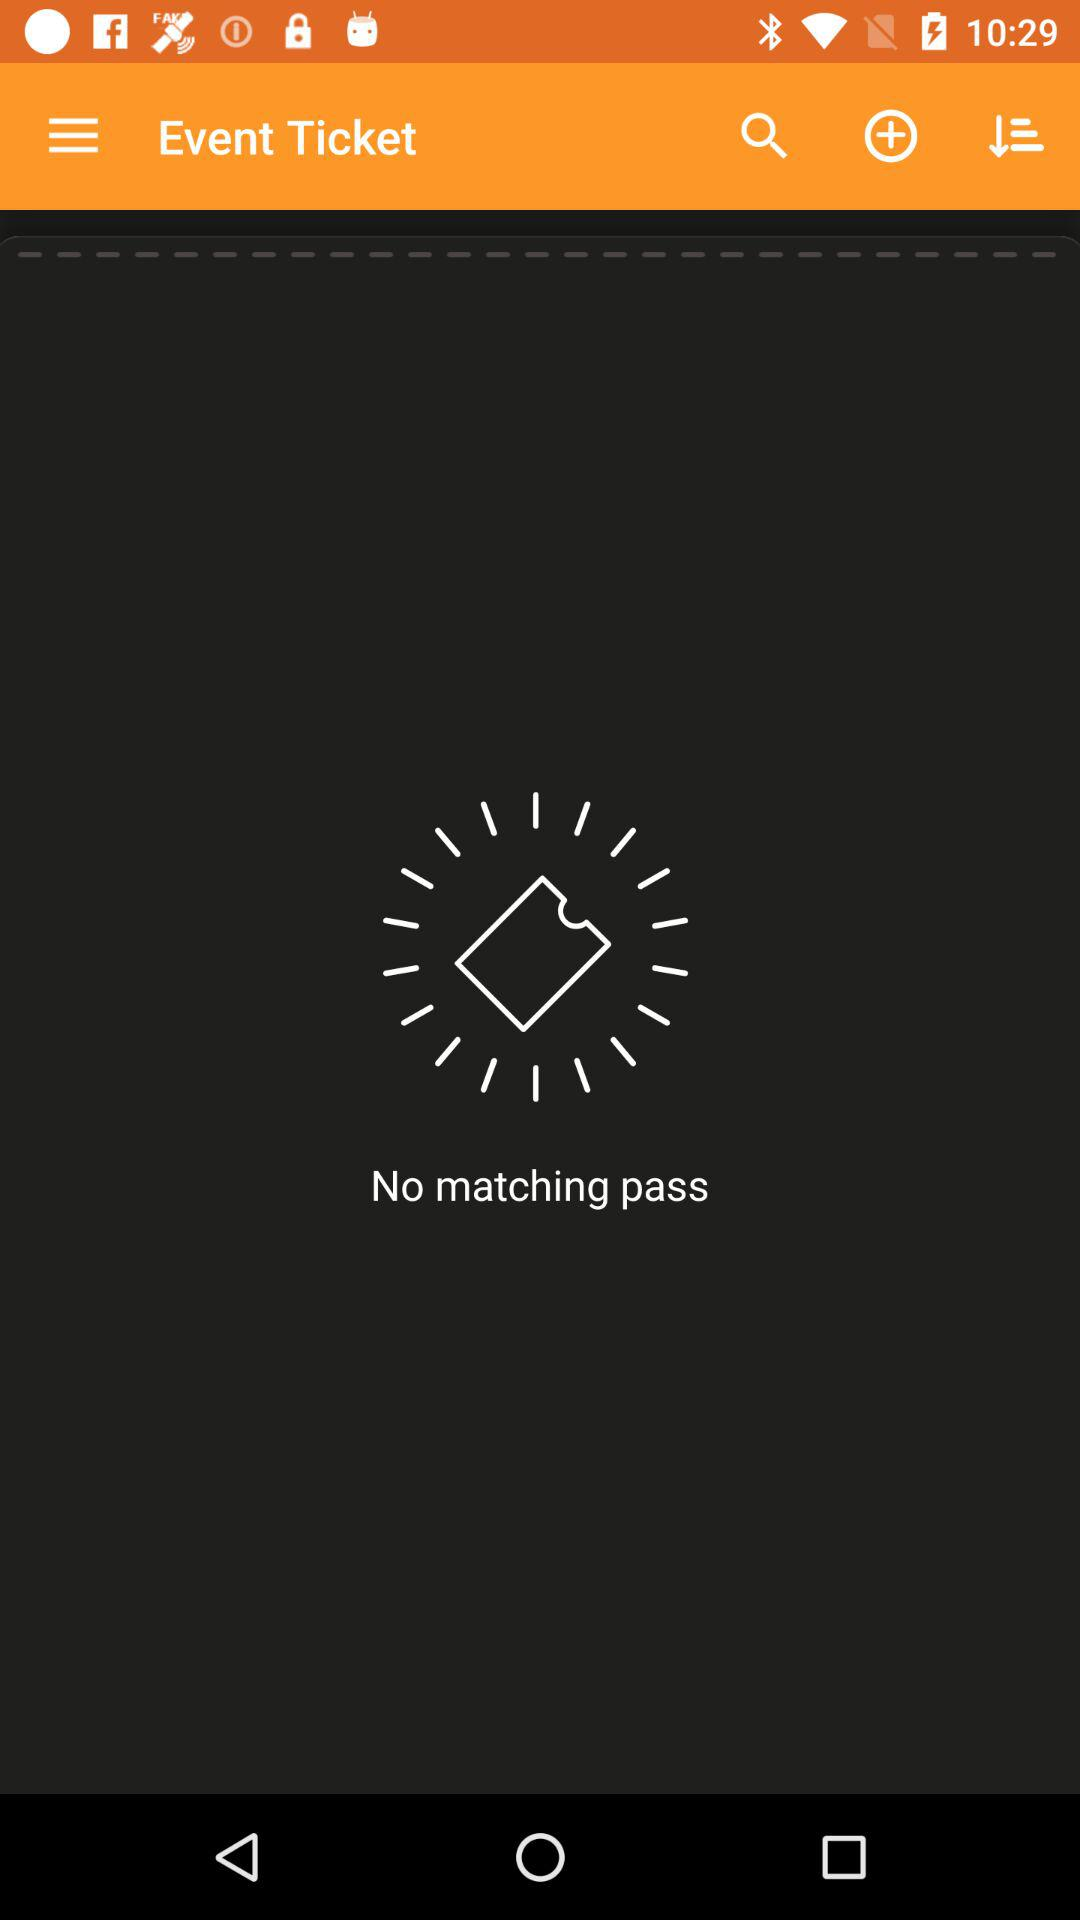How many matching passes are there? There is no matching pass. 